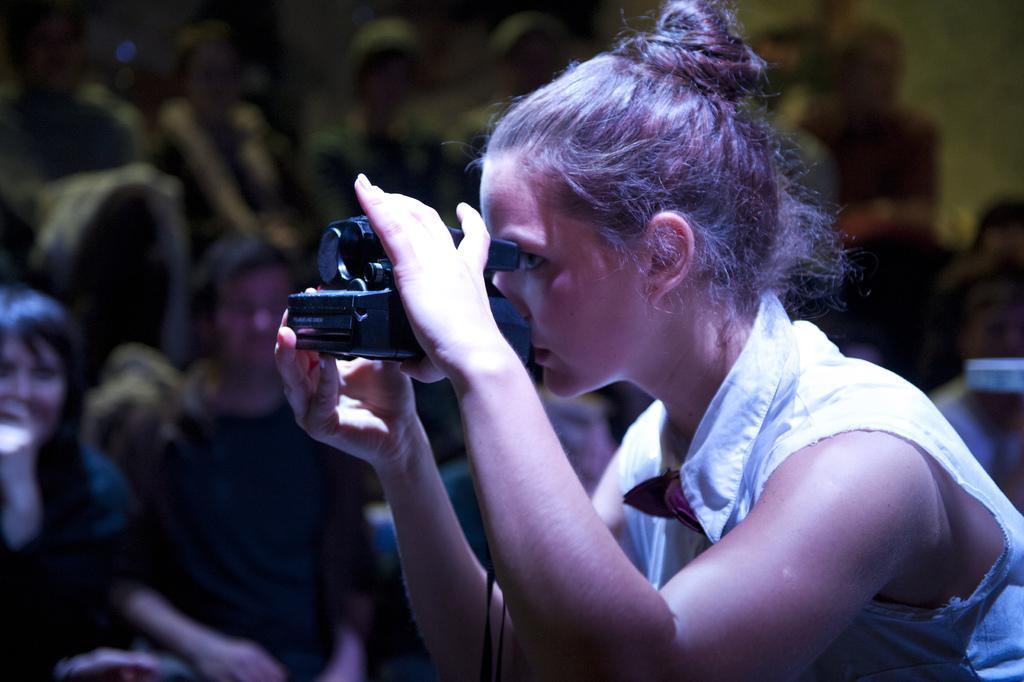Describe this image in one or two sentences. There is a lady wearing a white dress is holding a camera. In the background there are some people. 